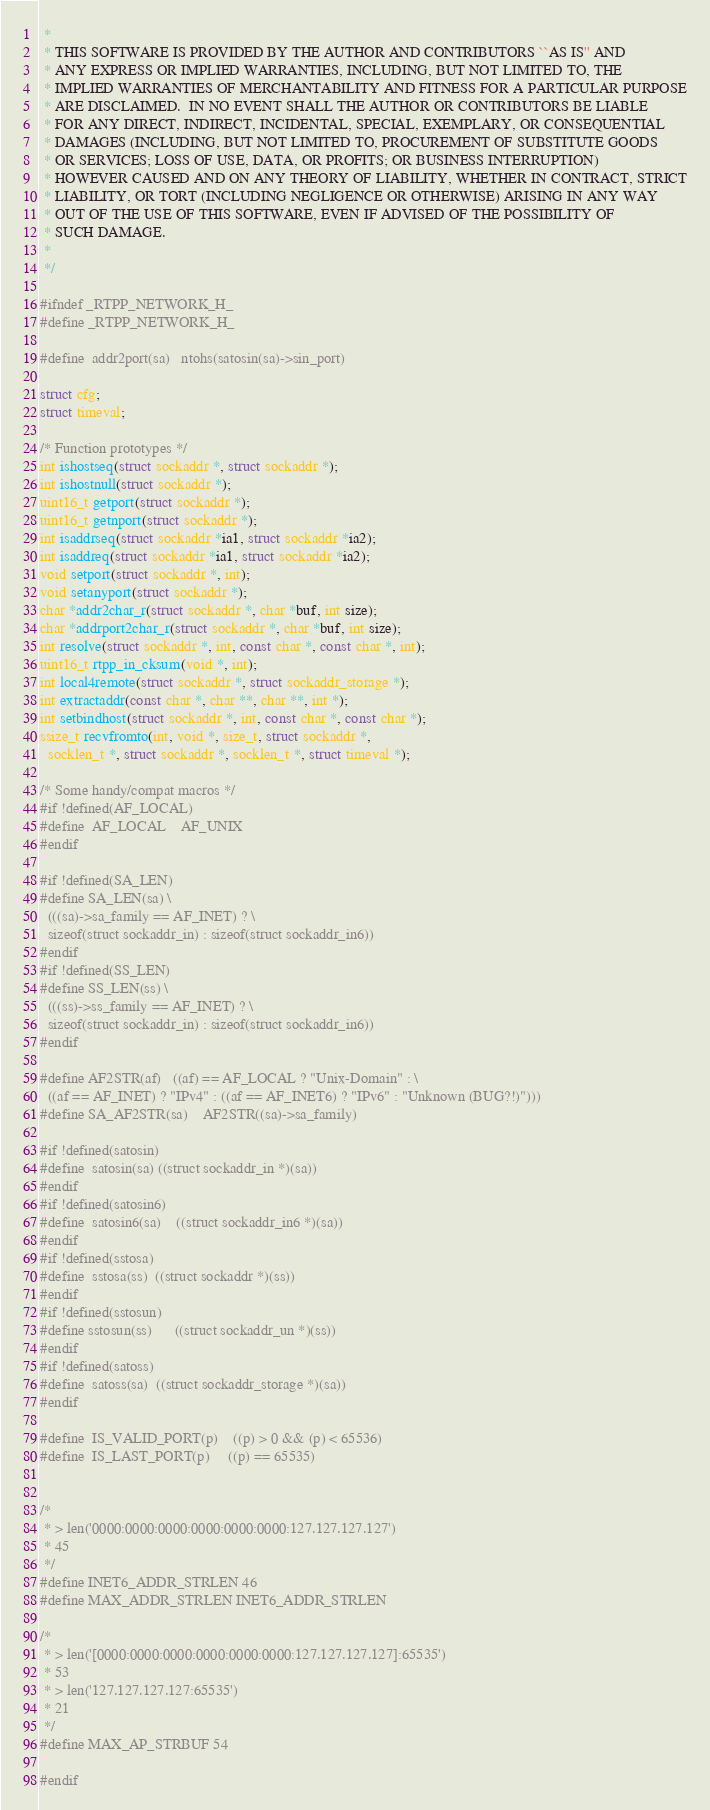Convert code to text. <code><loc_0><loc_0><loc_500><loc_500><_C_> *
 * THIS SOFTWARE IS PROVIDED BY THE AUTHOR AND CONTRIBUTORS ``AS IS'' AND
 * ANY EXPRESS OR IMPLIED WARRANTIES, INCLUDING, BUT NOT LIMITED TO, THE
 * IMPLIED WARRANTIES OF MERCHANTABILITY AND FITNESS FOR A PARTICULAR PURPOSE
 * ARE DISCLAIMED.  IN NO EVENT SHALL THE AUTHOR OR CONTRIBUTORS BE LIABLE
 * FOR ANY DIRECT, INDIRECT, INCIDENTAL, SPECIAL, EXEMPLARY, OR CONSEQUENTIAL
 * DAMAGES (INCLUDING, BUT NOT LIMITED TO, PROCUREMENT OF SUBSTITUTE GOODS
 * OR SERVICES; LOSS OF USE, DATA, OR PROFITS; OR BUSINESS INTERRUPTION)
 * HOWEVER CAUSED AND ON ANY THEORY OF LIABILITY, WHETHER IN CONTRACT, STRICT
 * LIABILITY, OR TORT (INCLUDING NEGLIGENCE OR OTHERWISE) ARISING IN ANY WAY
 * OUT OF THE USE OF THIS SOFTWARE, EVEN IF ADVISED OF THE POSSIBILITY OF
 * SUCH DAMAGE.
 *
 */

#ifndef _RTPP_NETWORK_H_
#define _RTPP_NETWORK_H_

#define	addr2port(sa)	ntohs(satosin(sa)->sin_port)

struct cfg;
struct timeval;

/* Function prototypes */
int ishostseq(struct sockaddr *, struct sockaddr *);
int ishostnull(struct sockaddr *);
uint16_t getport(struct sockaddr *);
uint16_t getnport(struct sockaddr *);
int isaddrseq(struct sockaddr *ia1, struct sockaddr *ia2);
int isaddreq(struct sockaddr *ia1, struct sockaddr *ia2);
void setport(struct sockaddr *, int);
void setanyport(struct sockaddr *);
char *addr2char_r(struct sockaddr *, char *buf, int size);
char *addrport2char_r(struct sockaddr *, char *buf, int size);
int resolve(struct sockaddr *, int, const char *, const char *, int);
uint16_t rtpp_in_cksum(void *, int);
int local4remote(struct sockaddr *, struct sockaddr_storage *);
int extractaddr(const char *, char **, char **, int *);
int setbindhost(struct sockaddr *, int, const char *, const char *);
ssize_t recvfromto(int, void *, size_t, struct sockaddr *,
  socklen_t *, struct sockaddr *, socklen_t *, struct timeval *);

/* Some handy/compat macros */
#if !defined(AF_LOCAL)
#define	AF_LOCAL	AF_UNIX
#endif

#if !defined(SA_LEN)
#define SA_LEN(sa) \
  (((sa)->sa_family == AF_INET) ? \
  sizeof(struct sockaddr_in) : sizeof(struct sockaddr_in6))
#endif
#if !defined(SS_LEN)
#define SS_LEN(ss) \
  (((ss)->ss_family == AF_INET) ? \
  sizeof(struct sockaddr_in) : sizeof(struct sockaddr_in6))
#endif

#define AF2STR(af) 	((af) == AF_LOCAL ? "Unix-Domain" : \
  ((af == AF_INET) ? "IPv4" : ((af == AF_INET6) ? "IPv6" : "Unknown (BUG?!)")))
#define SA_AF2STR(sa)	AF2STR((sa)->sa_family)

#if !defined(satosin)
#define	satosin(sa)	((struct sockaddr_in *)(sa))
#endif
#if !defined(satosin6)
#define	satosin6(sa)	((struct sockaddr_in6 *)(sa))
#endif
#if !defined(sstosa)
#define	sstosa(ss)	((struct sockaddr *)(ss))
#endif
#if !defined(sstosun)
#define sstosun(ss)      ((struct sockaddr_un *)(ss))
#endif
#if !defined(satoss)
#define	satoss(sa)	((struct sockaddr_storage *)(sa))
#endif

#define	IS_VALID_PORT(p)	((p) > 0 && (p) < 65536)
#define	IS_LAST_PORT(p)		((p) == 65535)


/*
 * > len('0000:0000:0000:0000:0000:0000:127.127.127.127')
 * 45
 */
#define INET6_ADDR_STRLEN 46
#define MAX_ADDR_STRLEN INET6_ADDR_STRLEN

/*
 * > len('[0000:0000:0000:0000:0000:0000:127.127.127.127]:65535')
 * 53
 * > len('127.127.127.127:65535')
 * 21
 */
#define MAX_AP_STRBUF 54

#endif
</code> 